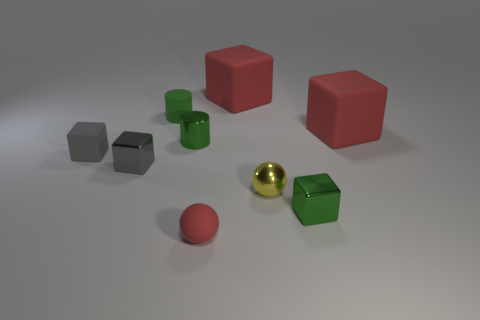Subtract all green cubes. How many cubes are left? 4 Subtract all green metal blocks. How many blocks are left? 4 Subtract all yellow blocks. Subtract all gray cylinders. How many blocks are left? 5 Subtract all balls. How many objects are left? 7 Add 2 big matte things. How many big matte things are left? 4 Add 2 big matte blocks. How many big matte blocks exist? 4 Subtract 2 gray blocks. How many objects are left? 7 Subtract all rubber cylinders. Subtract all red things. How many objects are left? 5 